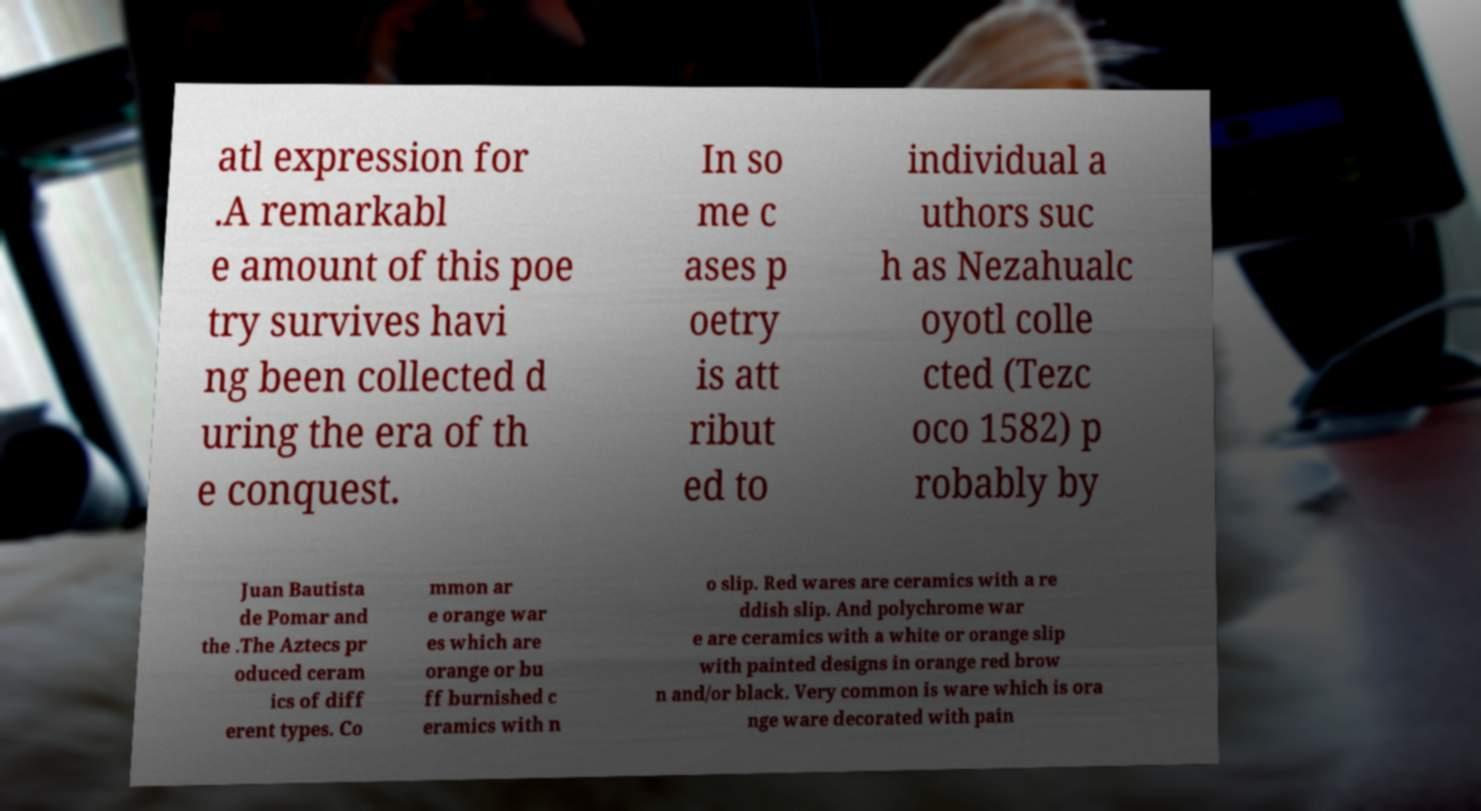Could you extract and type out the text from this image? atl expression for .A remarkabl e amount of this poe try survives havi ng been collected d uring the era of th e conquest. In so me c ases p oetry is att ribut ed to individual a uthors suc h as Nezahualc oyotl colle cted (Tezc oco 1582) p robably by Juan Bautista de Pomar and the .The Aztecs pr oduced ceram ics of diff erent types. Co mmon ar e orange war es which are orange or bu ff burnished c eramics with n o slip. Red wares are ceramics with a re ddish slip. And polychrome war e are ceramics with a white or orange slip with painted designs in orange red brow n and/or black. Very common is ware which is ora nge ware decorated with pain 